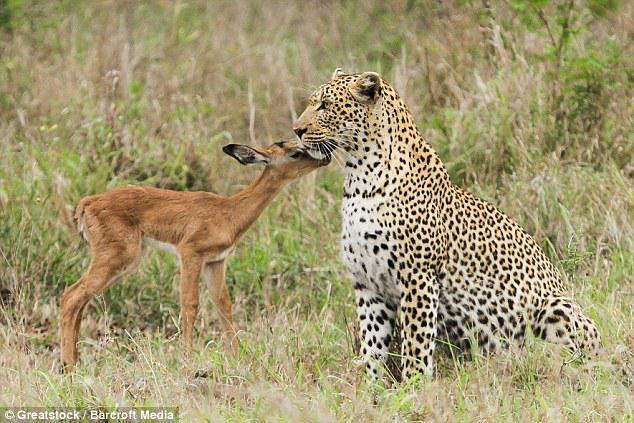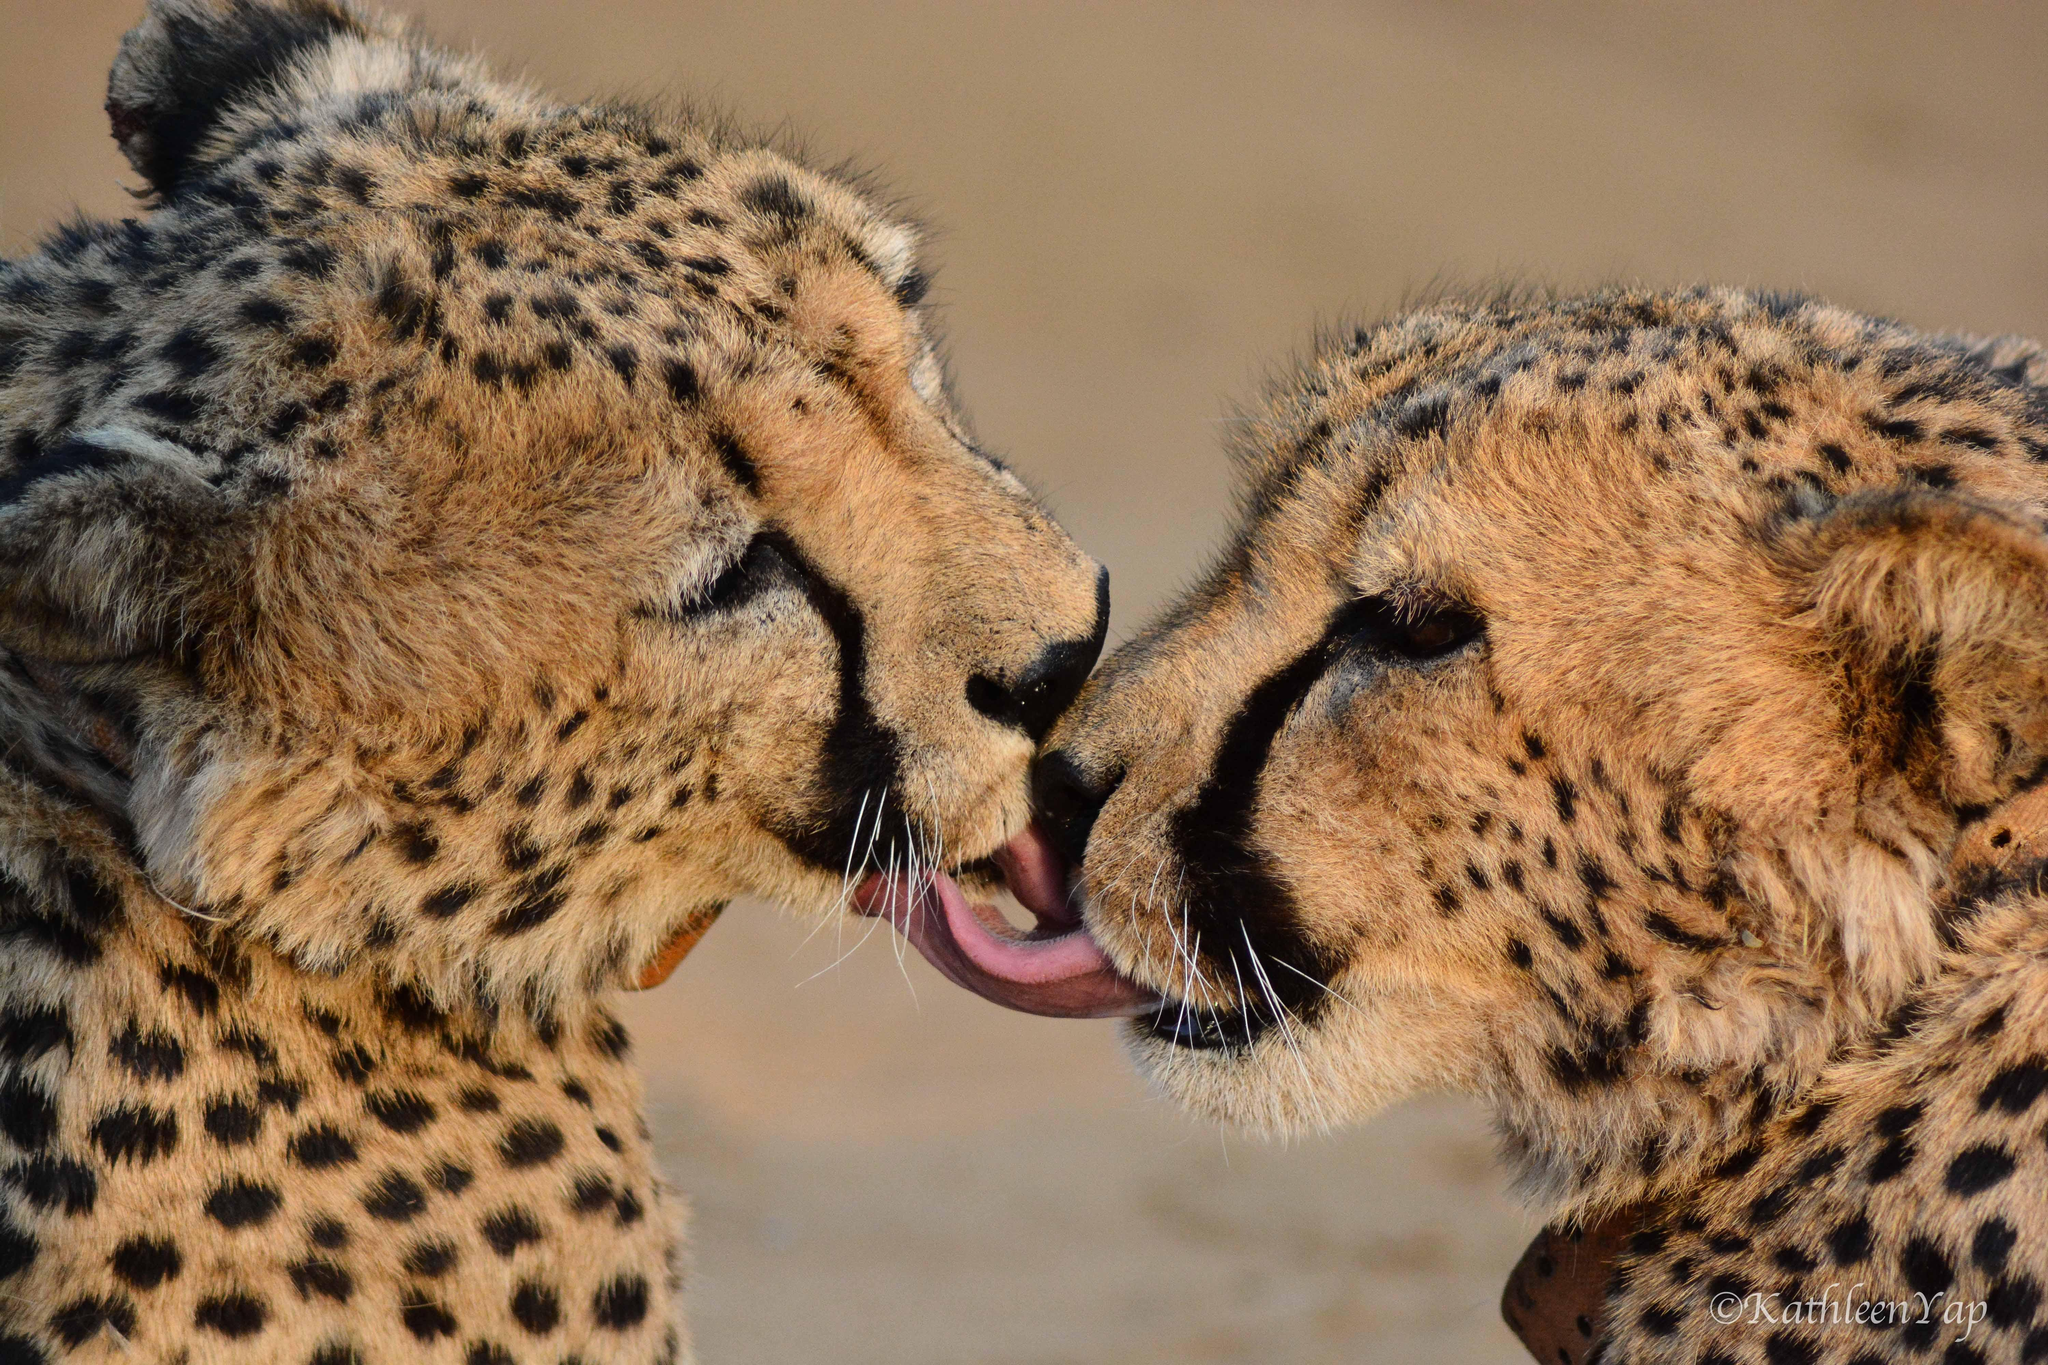The first image is the image on the left, the second image is the image on the right. For the images shown, is this caption "The left image shows two spotted wildcats face to face, with heads level, and the right image shows exactly one spotted wildcat licking the other." true? Answer yes or no. No. The first image is the image on the left, the second image is the image on the right. For the images displayed, is the sentence "At least one leopard's tongue is visible." factually correct? Answer yes or no. Yes. 